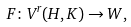Convert formula to latex. <formula><loc_0><loc_0><loc_500><loc_500>F \colon V ^ { r } ( H , K ) \to W ,</formula> 